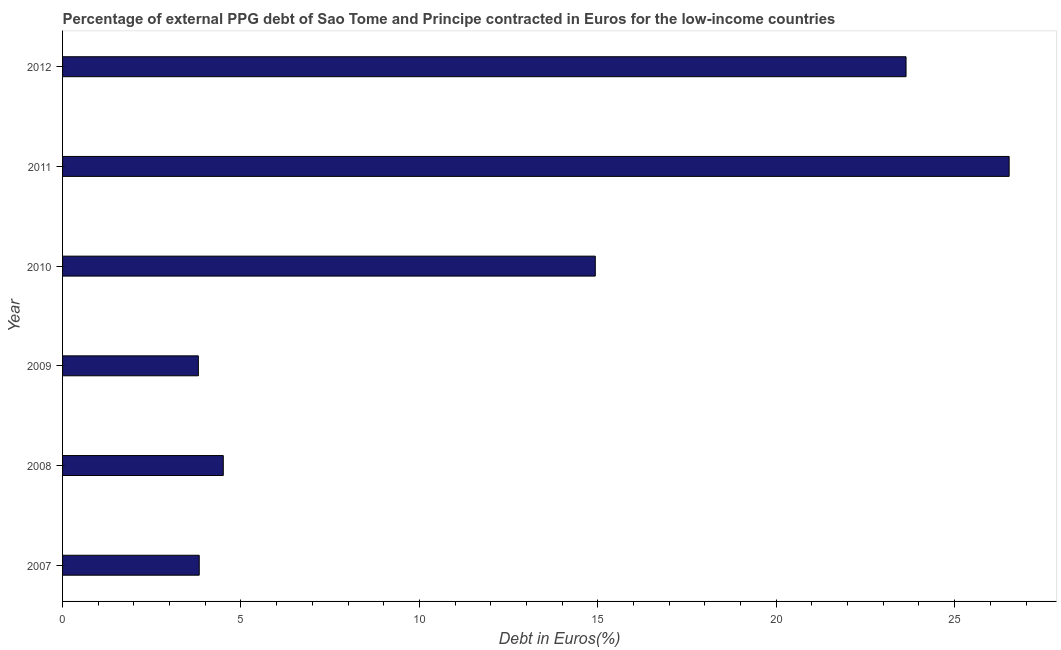What is the title of the graph?
Your answer should be compact. Percentage of external PPG debt of Sao Tome and Principe contracted in Euros for the low-income countries. What is the label or title of the X-axis?
Provide a succinct answer. Debt in Euros(%). What is the currency composition of ppg debt in 2008?
Your answer should be very brief. 4.5. Across all years, what is the maximum currency composition of ppg debt?
Offer a terse response. 26.53. Across all years, what is the minimum currency composition of ppg debt?
Offer a terse response. 3.81. In which year was the currency composition of ppg debt maximum?
Your response must be concise. 2011. What is the sum of the currency composition of ppg debt?
Make the answer very short. 77.24. What is the difference between the currency composition of ppg debt in 2009 and 2010?
Your answer should be very brief. -11.12. What is the average currency composition of ppg debt per year?
Make the answer very short. 12.87. What is the median currency composition of ppg debt?
Your answer should be compact. 9.72. In how many years, is the currency composition of ppg debt greater than 22 %?
Offer a terse response. 2. Do a majority of the years between 2009 and 2011 (inclusive) have currency composition of ppg debt greater than 26 %?
Make the answer very short. No. What is the ratio of the currency composition of ppg debt in 2009 to that in 2011?
Your answer should be compact. 0.14. Is the difference between the currency composition of ppg debt in 2008 and 2010 greater than the difference between any two years?
Ensure brevity in your answer.  No. What is the difference between the highest and the second highest currency composition of ppg debt?
Make the answer very short. 2.89. Is the sum of the currency composition of ppg debt in 2007 and 2010 greater than the maximum currency composition of ppg debt across all years?
Provide a short and direct response. No. What is the difference between the highest and the lowest currency composition of ppg debt?
Ensure brevity in your answer.  22.72. In how many years, is the currency composition of ppg debt greater than the average currency composition of ppg debt taken over all years?
Offer a terse response. 3. What is the Debt in Euros(%) of 2007?
Keep it short and to the point. 3.83. What is the Debt in Euros(%) of 2008?
Your answer should be compact. 4.5. What is the Debt in Euros(%) of 2009?
Ensure brevity in your answer.  3.81. What is the Debt in Euros(%) of 2010?
Offer a terse response. 14.93. What is the Debt in Euros(%) of 2011?
Ensure brevity in your answer.  26.53. What is the Debt in Euros(%) of 2012?
Offer a very short reply. 23.64. What is the difference between the Debt in Euros(%) in 2007 and 2008?
Offer a terse response. -0.67. What is the difference between the Debt in Euros(%) in 2007 and 2009?
Make the answer very short. 0.02. What is the difference between the Debt in Euros(%) in 2007 and 2010?
Your answer should be very brief. -11.1. What is the difference between the Debt in Euros(%) in 2007 and 2011?
Your answer should be very brief. -22.7. What is the difference between the Debt in Euros(%) in 2007 and 2012?
Your answer should be compact. -19.81. What is the difference between the Debt in Euros(%) in 2008 and 2009?
Provide a short and direct response. 0.7. What is the difference between the Debt in Euros(%) in 2008 and 2010?
Offer a terse response. -10.43. What is the difference between the Debt in Euros(%) in 2008 and 2011?
Your answer should be very brief. -22.02. What is the difference between the Debt in Euros(%) in 2008 and 2012?
Keep it short and to the point. -19.13. What is the difference between the Debt in Euros(%) in 2009 and 2010?
Your answer should be compact. -11.12. What is the difference between the Debt in Euros(%) in 2009 and 2011?
Provide a short and direct response. -22.72. What is the difference between the Debt in Euros(%) in 2009 and 2012?
Keep it short and to the point. -19.83. What is the difference between the Debt in Euros(%) in 2010 and 2011?
Ensure brevity in your answer.  -11.6. What is the difference between the Debt in Euros(%) in 2010 and 2012?
Keep it short and to the point. -8.71. What is the difference between the Debt in Euros(%) in 2011 and 2012?
Ensure brevity in your answer.  2.89. What is the ratio of the Debt in Euros(%) in 2007 to that in 2008?
Keep it short and to the point. 0.85. What is the ratio of the Debt in Euros(%) in 2007 to that in 2009?
Keep it short and to the point. 1.01. What is the ratio of the Debt in Euros(%) in 2007 to that in 2010?
Provide a short and direct response. 0.26. What is the ratio of the Debt in Euros(%) in 2007 to that in 2011?
Your answer should be compact. 0.14. What is the ratio of the Debt in Euros(%) in 2007 to that in 2012?
Ensure brevity in your answer.  0.16. What is the ratio of the Debt in Euros(%) in 2008 to that in 2009?
Provide a short and direct response. 1.18. What is the ratio of the Debt in Euros(%) in 2008 to that in 2010?
Your response must be concise. 0.3. What is the ratio of the Debt in Euros(%) in 2008 to that in 2011?
Your answer should be very brief. 0.17. What is the ratio of the Debt in Euros(%) in 2008 to that in 2012?
Make the answer very short. 0.19. What is the ratio of the Debt in Euros(%) in 2009 to that in 2010?
Your answer should be compact. 0.26. What is the ratio of the Debt in Euros(%) in 2009 to that in 2011?
Give a very brief answer. 0.14. What is the ratio of the Debt in Euros(%) in 2009 to that in 2012?
Your answer should be compact. 0.16. What is the ratio of the Debt in Euros(%) in 2010 to that in 2011?
Make the answer very short. 0.56. What is the ratio of the Debt in Euros(%) in 2010 to that in 2012?
Offer a terse response. 0.63. What is the ratio of the Debt in Euros(%) in 2011 to that in 2012?
Make the answer very short. 1.12. 